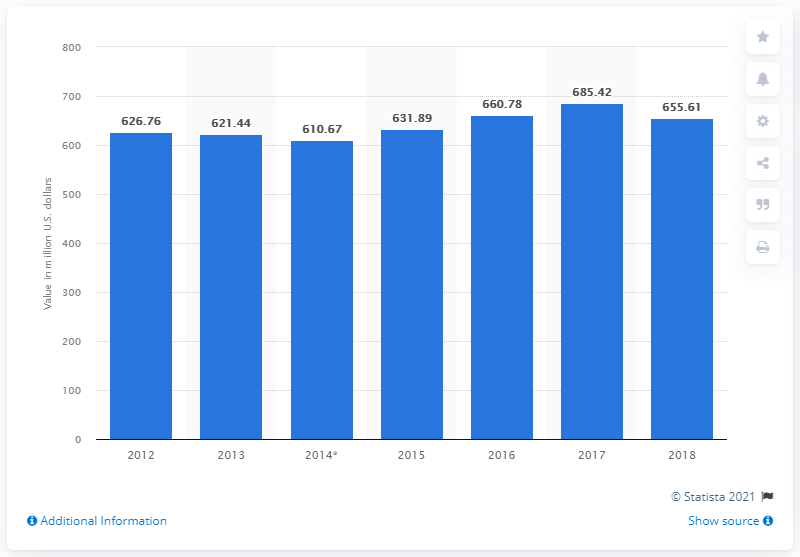How many dollars worth of cocoa was exported from Mexico in 2018?
 655.61 